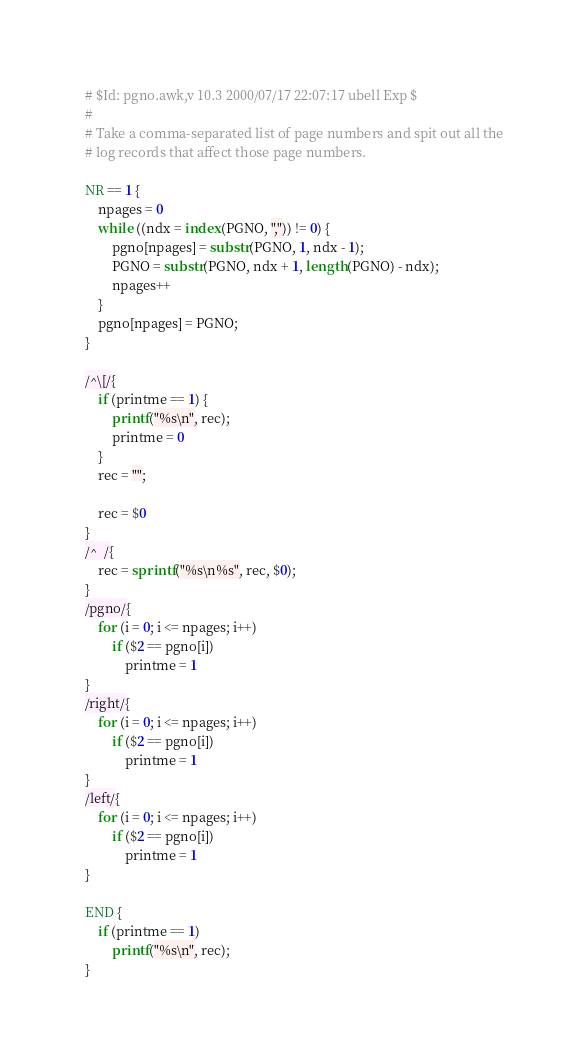Convert code to text. <code><loc_0><loc_0><loc_500><loc_500><_Awk_># $Id: pgno.awk,v 10.3 2000/07/17 22:07:17 ubell Exp $
#
# Take a comma-separated list of page numbers and spit out all the
# log records that affect those page numbers.

NR == 1 {
	npages = 0
	while ((ndx = index(PGNO, ",")) != 0) {
		pgno[npages] = substr(PGNO, 1, ndx - 1);
		PGNO = substr(PGNO, ndx + 1, length(PGNO) - ndx);
		npages++
	}
	pgno[npages] = PGNO;
}

/^\[/{
	if (printme == 1) {
		printf("%s\n", rec);
		printme = 0
	}
	rec = "";

	rec = $0
}
/^	/{
	rec = sprintf("%s\n%s", rec, $0);
}
/pgno/{
	for (i = 0; i <= npages; i++)
		if ($2 == pgno[i])
			printme = 1
}
/right/{
	for (i = 0; i <= npages; i++)
		if ($2 == pgno[i])
			printme = 1
}
/left/{
	for (i = 0; i <= npages; i++)
		if ($2 == pgno[i])
			printme = 1
}

END {
	if (printme == 1)
		printf("%s\n", rec);
}
</code> 